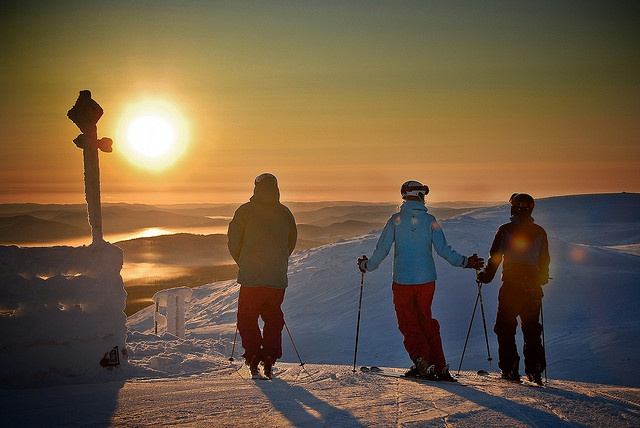Describe the objects in this image and their specific colors. I can see people in black, maroon, and gray tones, people in black, blue, gray, and maroon tones, people in black, maroon, and gray tones, skis in black and gray tones, and skis in black, gray, and maroon tones in this image. 